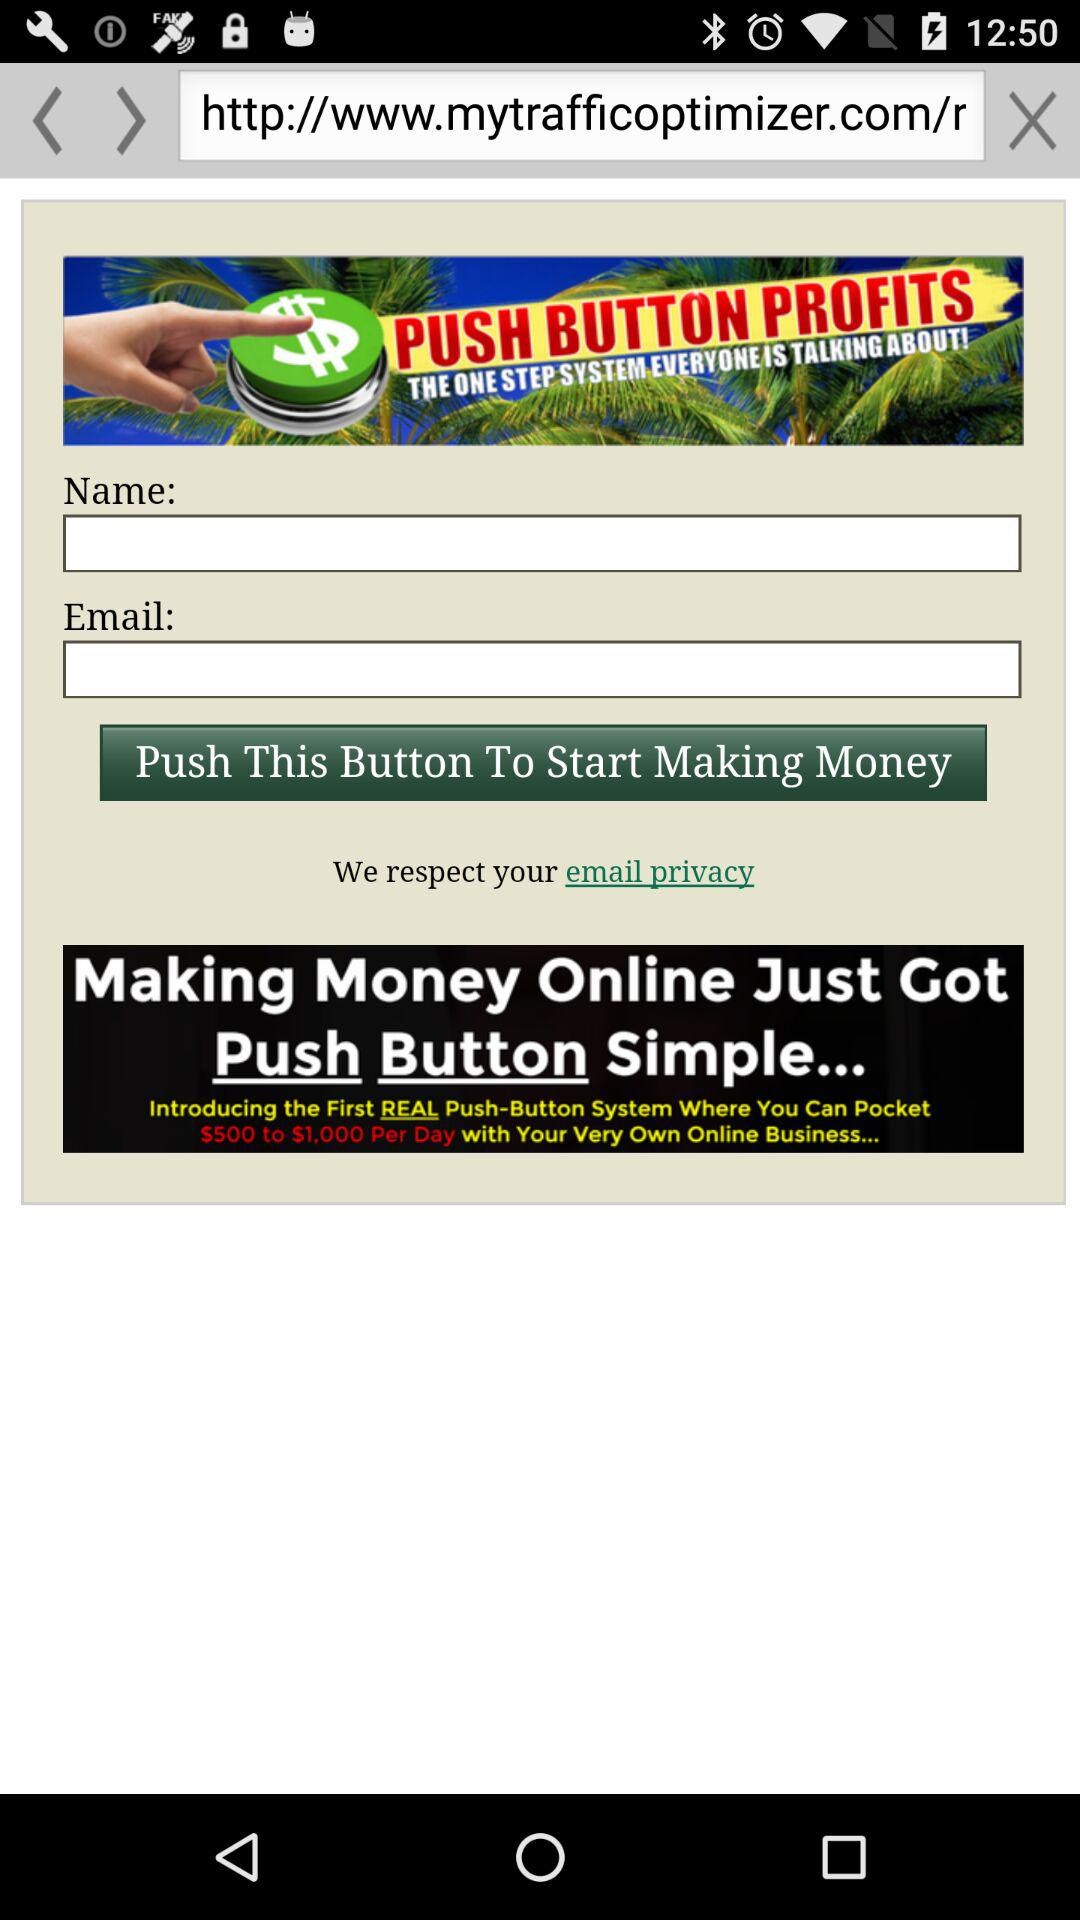What is the website's URL?
When the provided information is insufficient, respond with <no answer>. <no answer> 